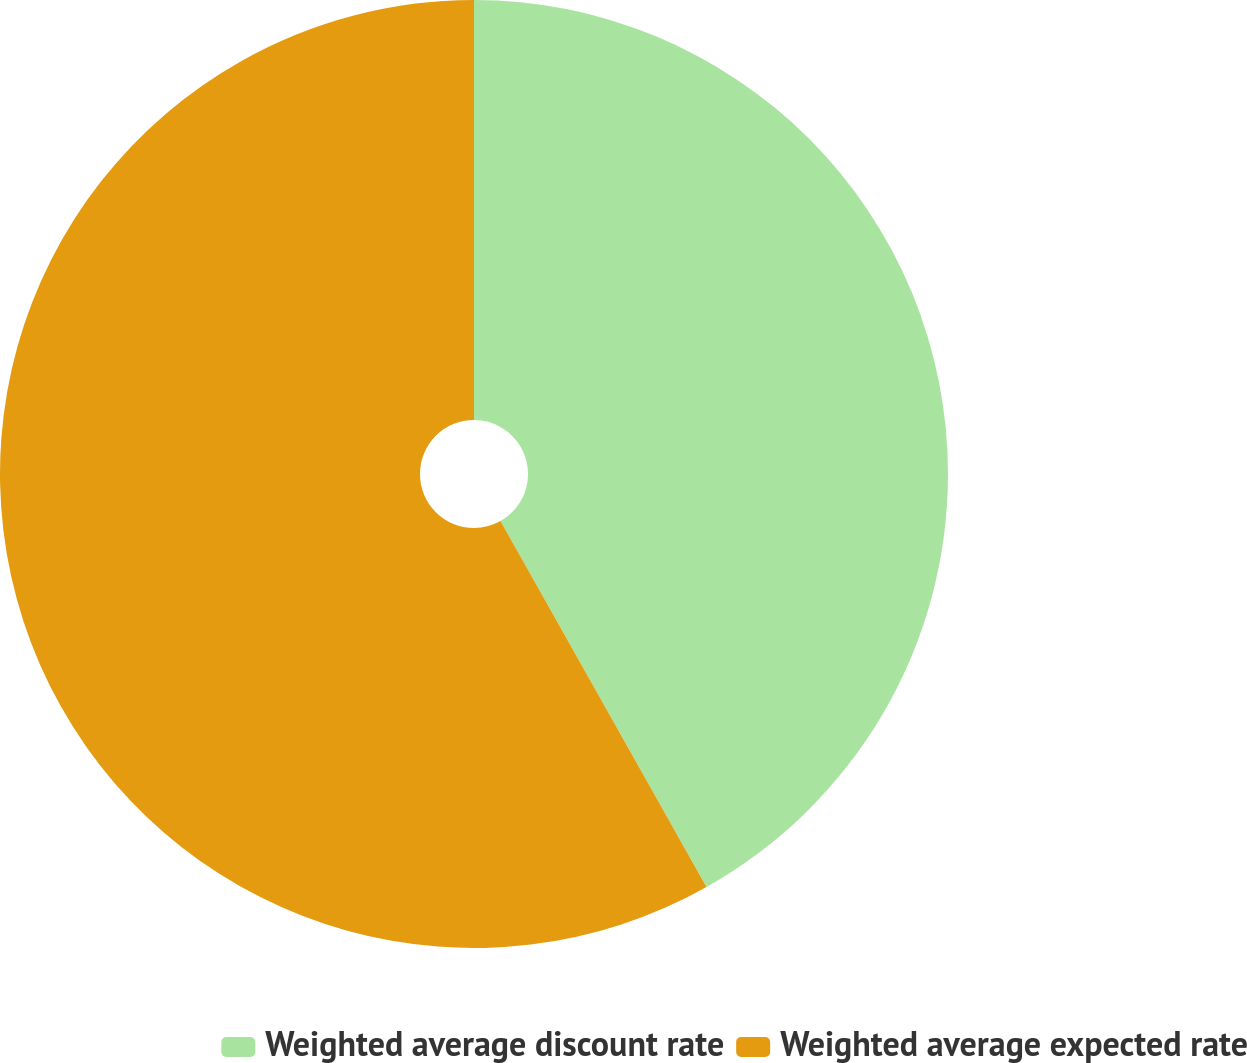Convert chart. <chart><loc_0><loc_0><loc_500><loc_500><pie_chart><fcel>Weighted average discount rate<fcel>Weighted average expected rate<nl><fcel>41.84%<fcel>58.16%<nl></chart> 